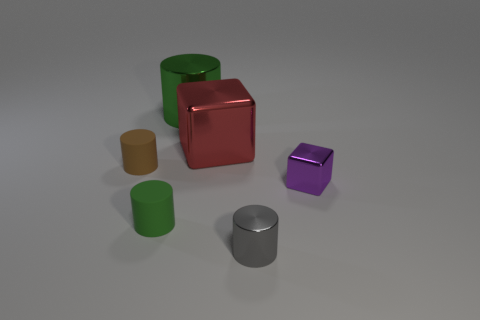Subtract all brown cylinders. How many cylinders are left? 3 Subtract all brown cylinders. How many cylinders are left? 3 Add 2 small blocks. How many objects exist? 8 Subtract all blocks. How many objects are left? 4 Subtract all cyan cubes. How many green cylinders are left? 2 Add 3 gray cylinders. How many gray cylinders are left? 4 Add 3 green cylinders. How many green cylinders exist? 5 Subtract 1 gray cylinders. How many objects are left? 5 Subtract 2 cylinders. How many cylinders are left? 2 Subtract all gray cylinders. Subtract all blue balls. How many cylinders are left? 3 